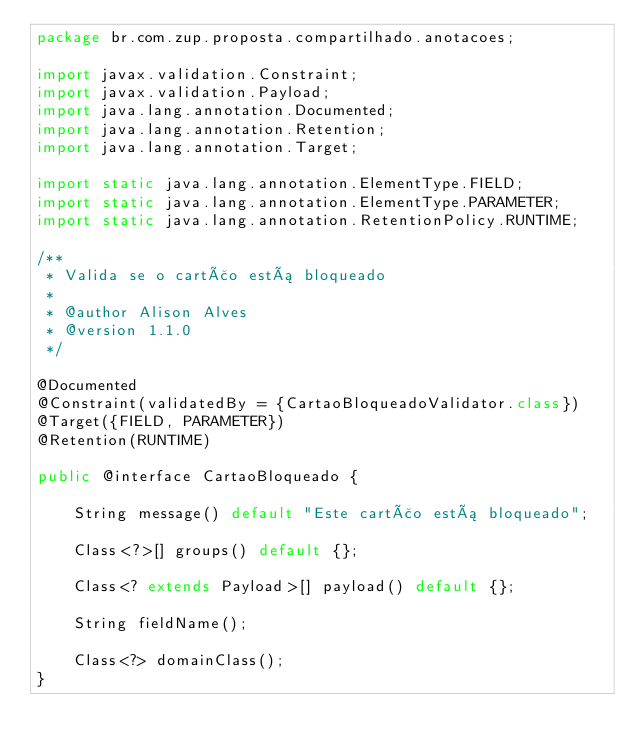Convert code to text. <code><loc_0><loc_0><loc_500><loc_500><_Java_>package br.com.zup.proposta.compartilhado.anotacoes;

import javax.validation.Constraint;
import javax.validation.Payload;
import java.lang.annotation.Documented;
import java.lang.annotation.Retention;
import java.lang.annotation.Target;

import static java.lang.annotation.ElementType.FIELD;
import static java.lang.annotation.ElementType.PARAMETER;
import static java.lang.annotation.RetentionPolicy.RUNTIME;

/**
 * Valida se o cartão está bloqueado
 *
 * @author Alison Alves
 * @version 1.1.0
 */

@Documented
@Constraint(validatedBy = {CartaoBloqueadoValidator.class})
@Target({FIELD, PARAMETER})
@Retention(RUNTIME)

public @interface CartaoBloqueado {

    String message() default "Este cartão está bloqueado";

    Class<?>[] groups() default {};

    Class<? extends Payload>[] payload() default {};

    String fieldName();

    Class<?> domainClass();
}
</code> 